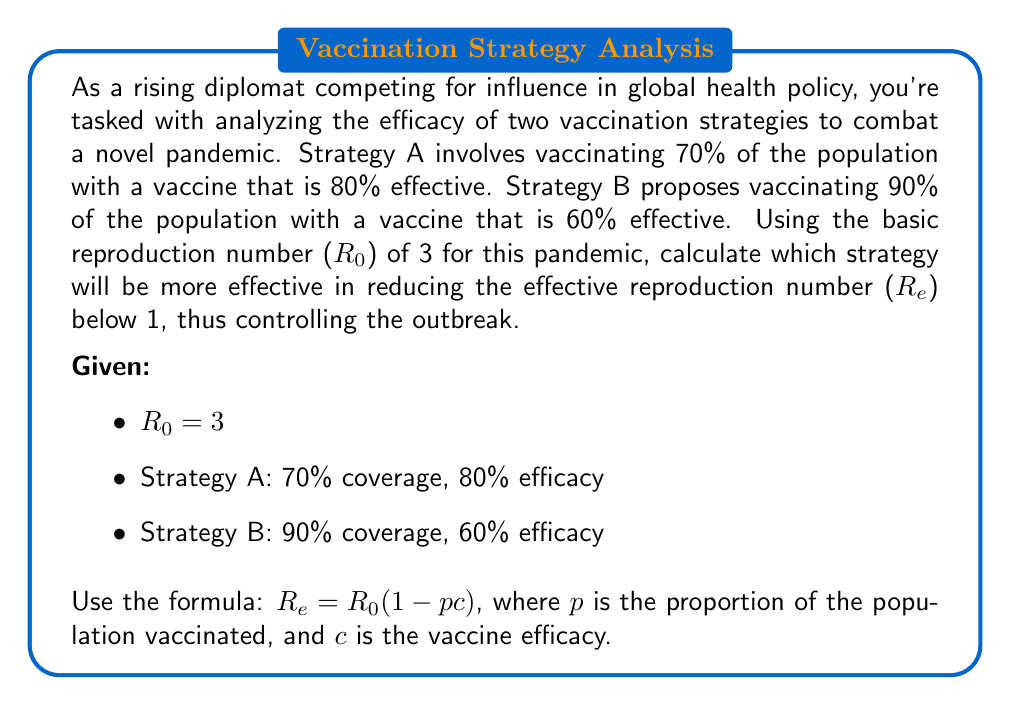Help me with this question. Let's approach this step-by-step:

1) We'll use the formula $R_e = R_0(1 - pc)$ for both strategies.

2) For Strategy A:
   $p_A = 0.70$ (70% coverage)
   $c_A = 0.80$ (80% efficacy)
   
   $R_{eA} = 3(1 - 0.70 \times 0.80)$
   $R_{eA} = 3(1 - 0.56)$
   $R_{eA} = 3 \times 0.44$
   $R_{eA} = 1.32$

3) For Strategy B:
   $p_B = 0.90$ (90% coverage)
   $c_B = 0.60$ (60% efficacy)
   
   $R_{eB} = 3(1 - 0.90 \times 0.60)$
   $R_{eB} = 3(1 - 0.54)$
   $R_{eB} = 3 \times 0.46$
   $R_{eB} = 1.38$

4) Comparing the results:
   Strategy A: $R_{eA} = 1.32$
   Strategy B: $R_{eB} = 1.38$

5) The lower $R_e$ value indicates better control of the outbreak. Strategy A has a lower $R_e$ value (1.32 < 1.38).

6) However, neither strategy reduces $R_e$ below 1, which is necessary to fully control the outbreak.
Answer: Strategy A is more effective ($R_e = 1.32$), but neither strategy reduces $R_e$ below 1. 